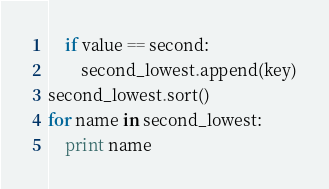<code> <loc_0><loc_0><loc_500><loc_500><_Python_>    if value == second:
        second_lowest.append(key)
second_lowest.sort()
for name in second_lowest:
    print name
</code> 